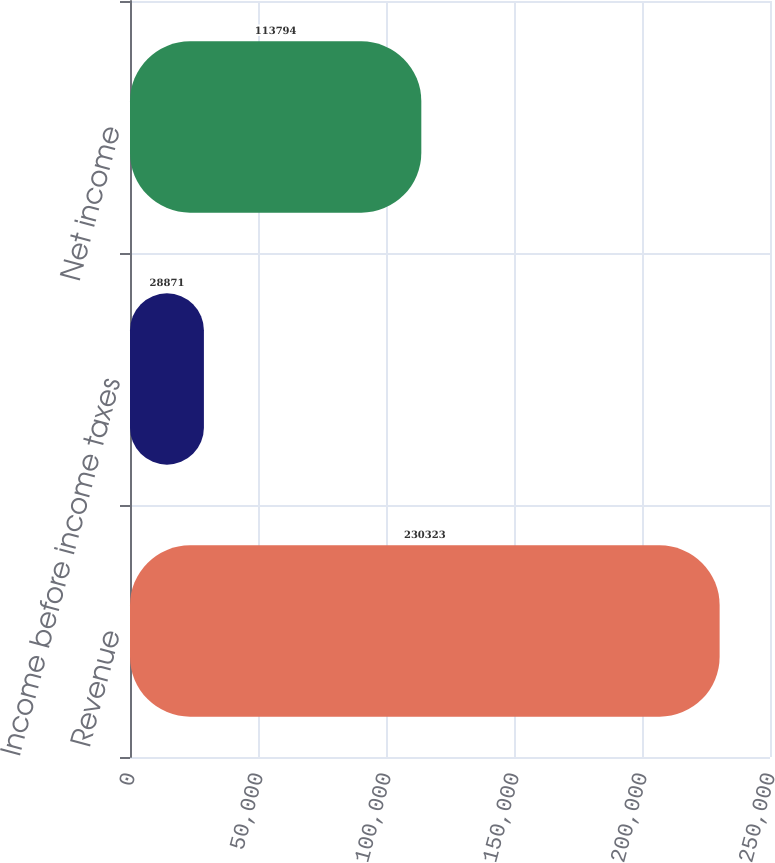<chart> <loc_0><loc_0><loc_500><loc_500><bar_chart><fcel>Revenue<fcel>Income before income taxes<fcel>Net income<nl><fcel>230323<fcel>28871<fcel>113794<nl></chart> 